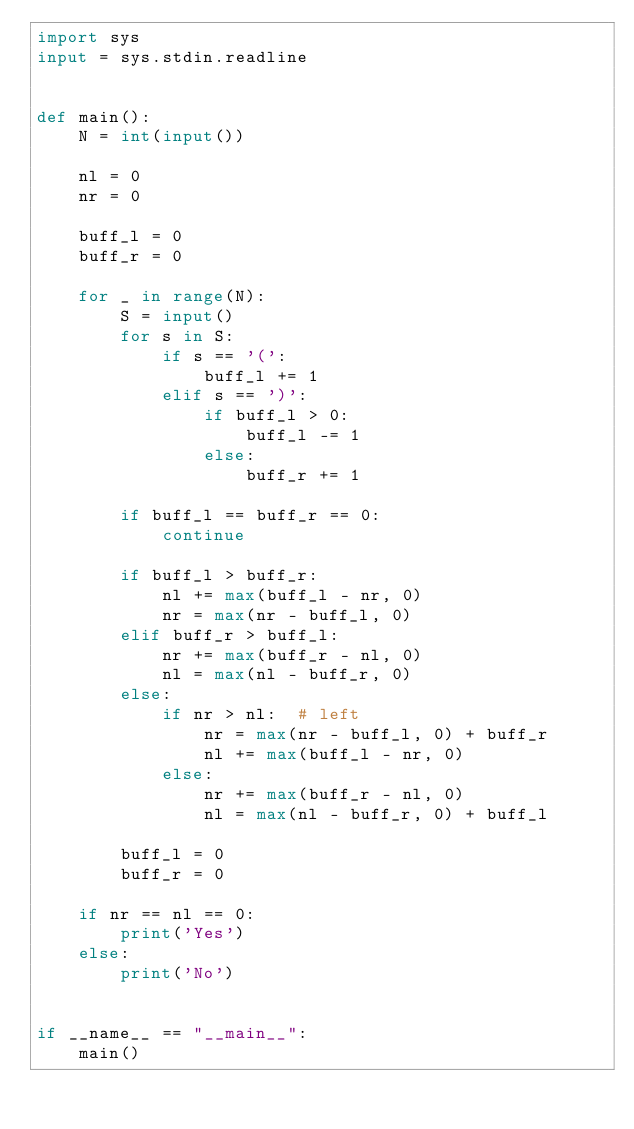Convert code to text. <code><loc_0><loc_0><loc_500><loc_500><_Python_>import sys
input = sys.stdin.readline


def main():
    N = int(input())

    nl = 0
    nr = 0

    buff_l = 0
    buff_r = 0

    for _ in range(N):
        S = input()
        for s in S:
            if s == '(':
                buff_l += 1
            elif s == ')':
                if buff_l > 0:
                    buff_l -= 1
                else:
                    buff_r += 1
        
        if buff_l == buff_r == 0:
            continue

        if buff_l > buff_r:
            nl += max(buff_l - nr, 0)
            nr = max(nr - buff_l, 0)
        elif buff_r > buff_l:
            nr += max(buff_r - nl, 0)
            nl = max(nl - buff_r, 0)
        else:
            if nr > nl:  # left
                nr = max(nr - buff_l, 0) + buff_r
                nl += max(buff_l - nr, 0)
            else:
                nr += max(buff_r - nl, 0)
                nl = max(nl - buff_r, 0) + buff_l

        buff_l = 0
        buff_r = 0

    if nr == nl == 0:
        print('Yes')
    else:
        print('No')


if __name__ == "__main__":
    main()
</code> 